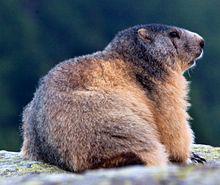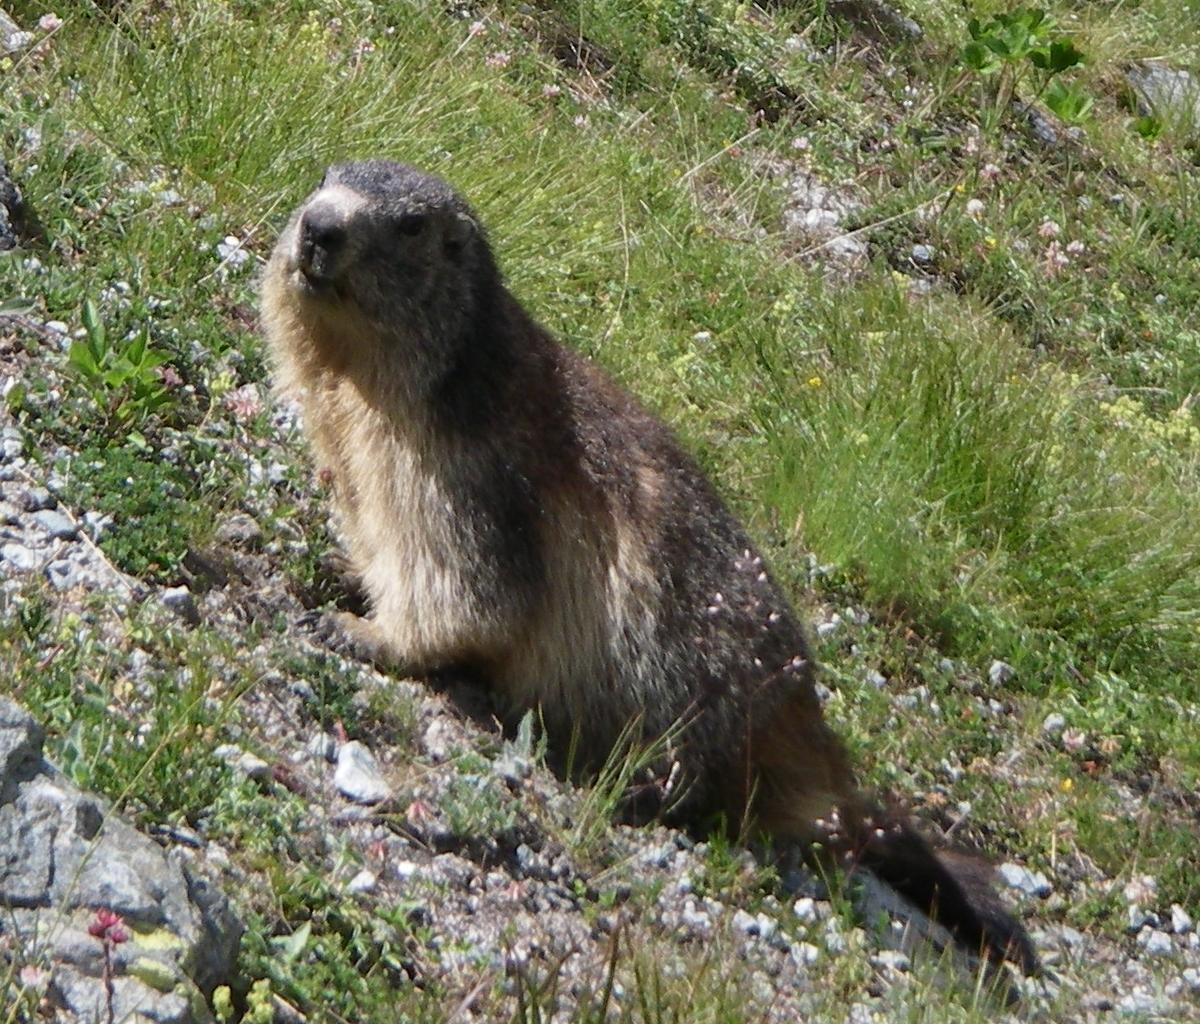The first image is the image on the left, the second image is the image on the right. For the images displayed, is the sentence "In one image there is a lone marmot looking towards the camera." factually correct? Answer yes or no. No. The first image is the image on the left, the second image is the image on the right. Evaluate the accuracy of this statement regarding the images: "A boy is kneeling on the ground as he plays with at least 3 groundhogs.". Is it true? Answer yes or no. No. 